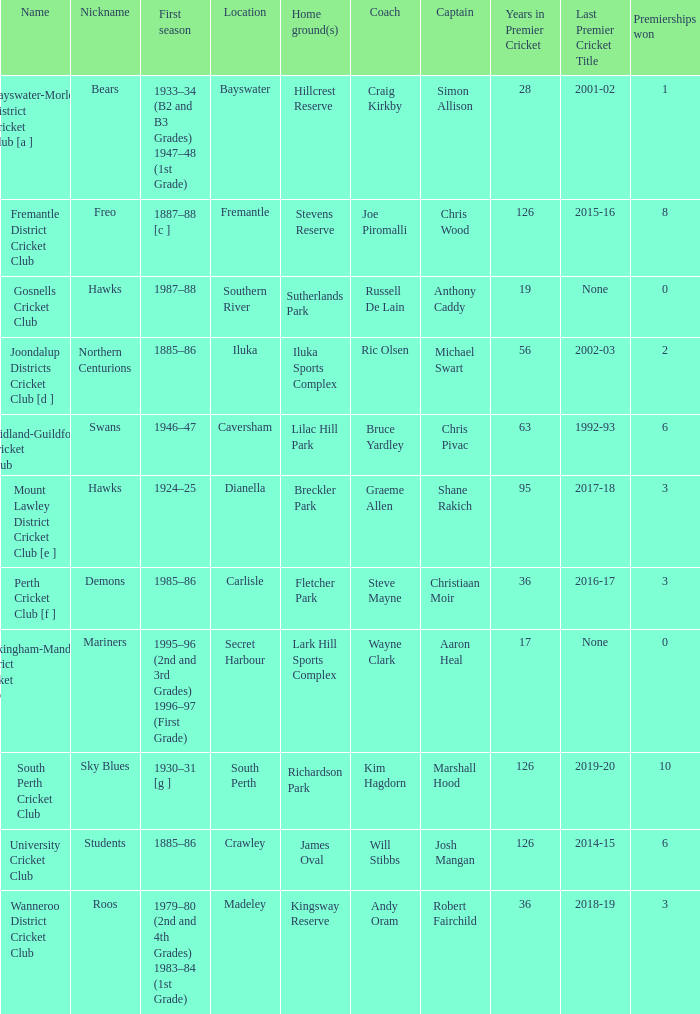What is the code nickname where Steve Mayne is the coach? Demons. 